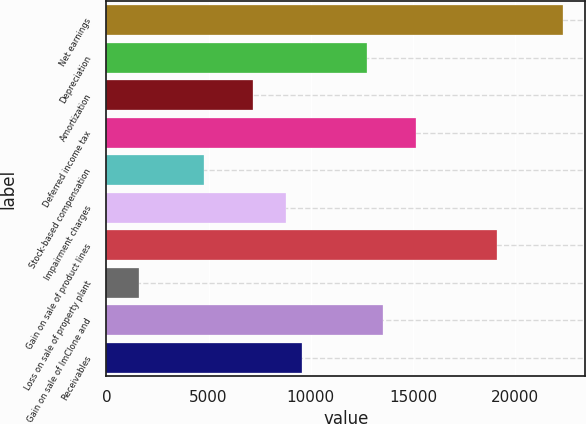Convert chart to OTSL. <chart><loc_0><loc_0><loc_500><loc_500><bar_chart><fcel>Net earnings<fcel>Depreciation<fcel>Amortization<fcel>Deferred income tax<fcel>Stock-based compensation<fcel>Impairment charges<fcel>Gain on sale of product lines<fcel>Loss on sale of property plant<fcel>Gain on sale of ImClone and<fcel>Receivables<nl><fcel>22323.8<fcel>12758.6<fcel>7178.9<fcel>15149.9<fcel>4787.6<fcel>8773.1<fcel>19135.4<fcel>1599.2<fcel>13555.7<fcel>9570.2<nl></chart> 